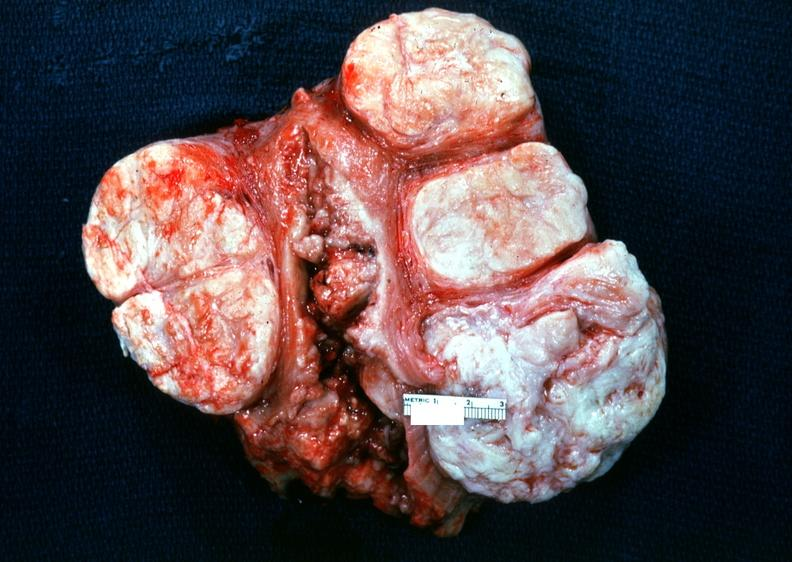what does this image show?
Answer the question using a single word or phrase. Uterus 